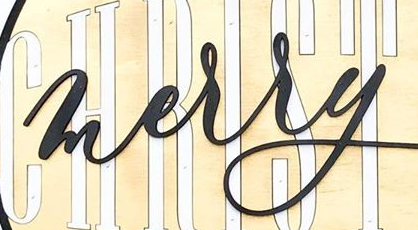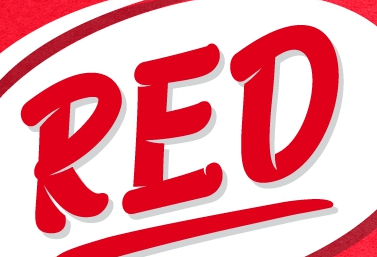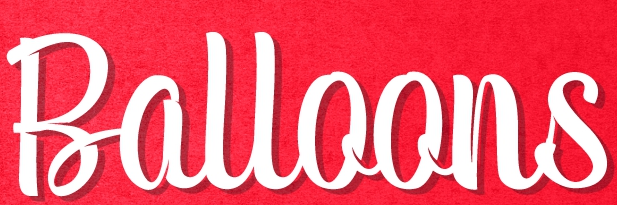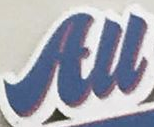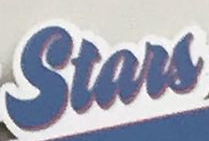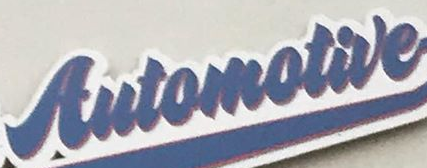Read the text content from these images in order, separated by a semicolon. merry; RED; Balloons; All; Stars; Automotive 